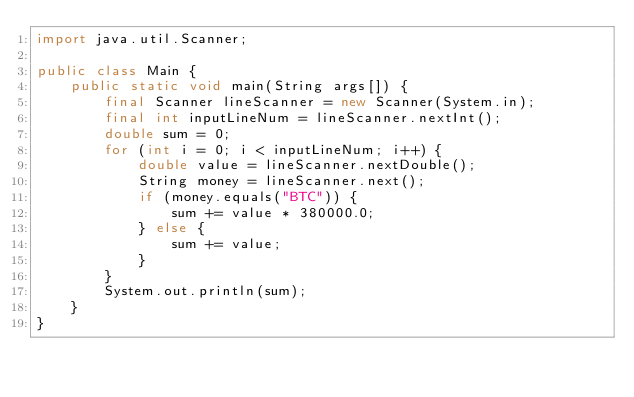<code> <loc_0><loc_0><loc_500><loc_500><_Java_>import java.util.Scanner;

public class Main {
    public static void main(String args[]) {
        final Scanner lineScanner = new Scanner(System.in);
        final int inputLineNum = lineScanner.nextInt();
        double sum = 0;
        for (int i = 0; i < inputLineNum; i++) {
            double value = lineScanner.nextDouble();
            String money = lineScanner.next();
            if (money.equals("BTC")) {
                sum += value * 380000.0;
            } else {
                sum += value;
            }
        }
        System.out.println(sum);
    }
}</code> 